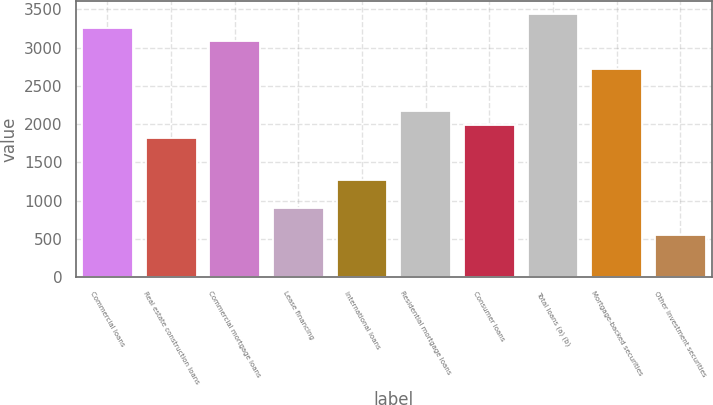<chart> <loc_0><loc_0><loc_500><loc_500><bar_chart><fcel>Commercial loans<fcel>Real estate construction loans<fcel>Commercial mortgage loans<fcel>Lease financing<fcel>International loans<fcel>Residential mortgage loans<fcel>Consumer loans<fcel>Total loans (a) (b)<fcel>Mortgage-backed securities<fcel>Other investment securities<nl><fcel>3261.8<fcel>1813<fcel>3080.7<fcel>907.5<fcel>1269.7<fcel>2175.2<fcel>1994.1<fcel>3442.9<fcel>2718.5<fcel>545.3<nl></chart> 